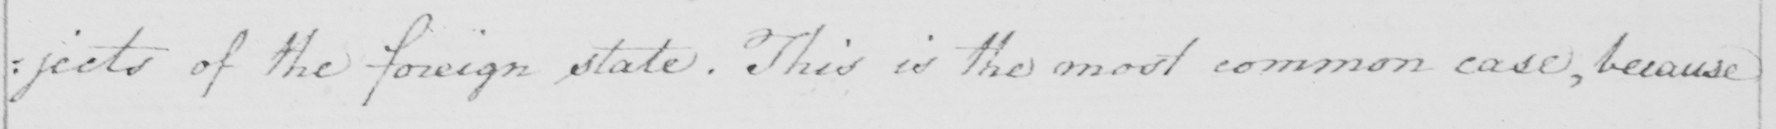Can you read and transcribe this handwriting? : jects of the foreign state . This is the most common case , because 